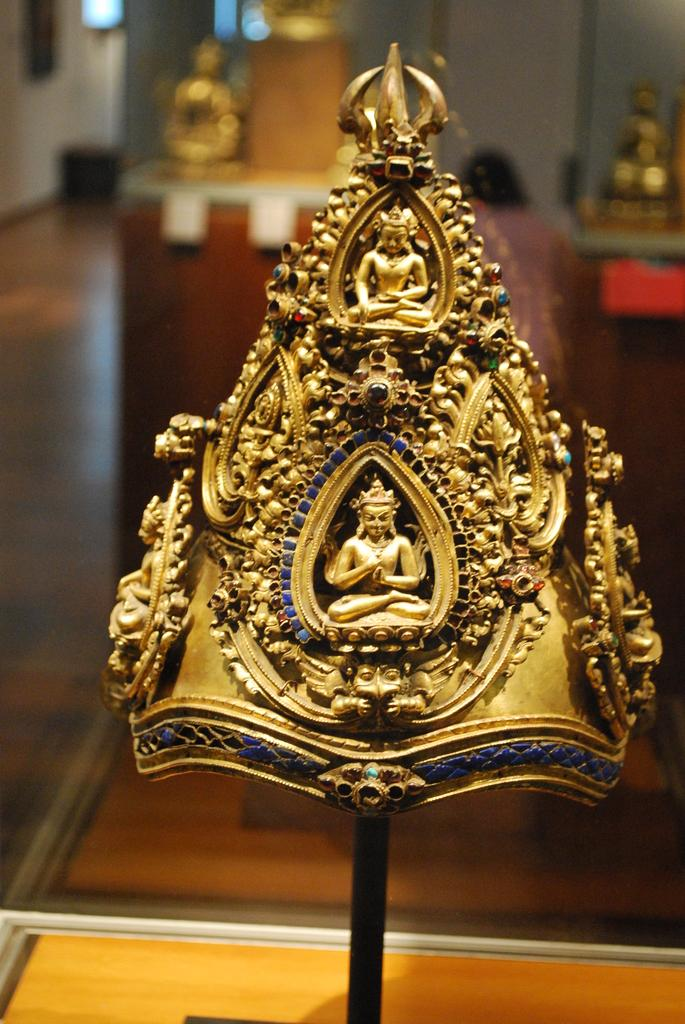What is the main object in the image? There is a crown in the image. Can you describe the background of the image? The background of the image is blurred. What scientific effect is being demonstrated in the image? There is no scientific effect being demonstrated in the image; it simply features a crown with a blurred background. 